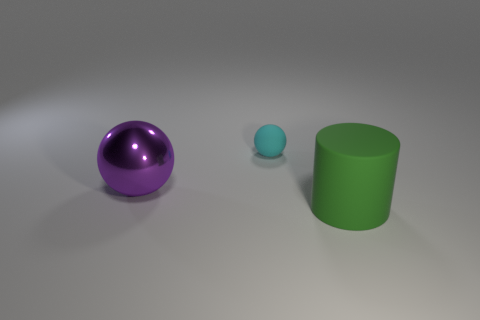How would you describe the arrangement of the objects? The objects are placed from left to right in decreasing order of size, with a large purple ball on the left, a small blue sphere in the middle, and a green cylinder on the right, all sitting on a flat surface.  If these objects represented a family, how would you describe their roles based on their positions and sizes? Metaphorically, the largest purple ball could represent a protective parental figure, the mid-sized blue sphere a child or younger sibling, and the sturdy green cylinder a supportive older sibling or secondary guardian, together illustrating a family dynamic. 